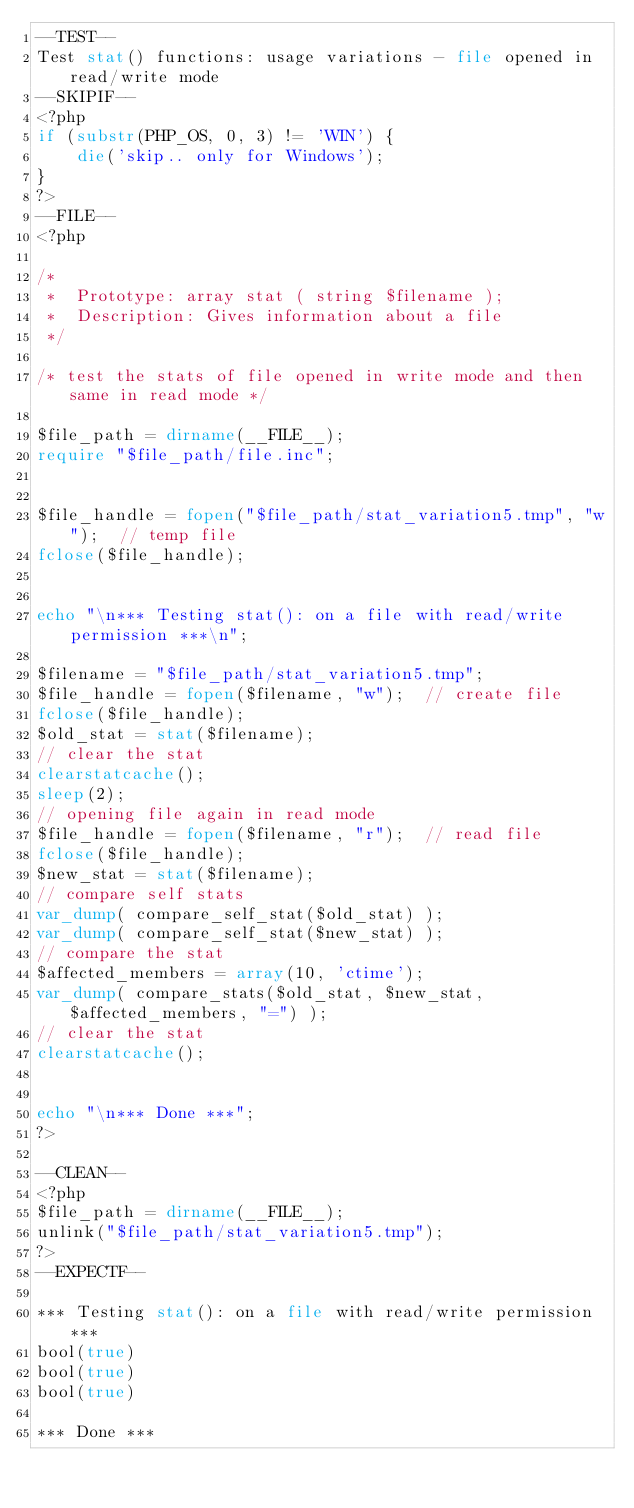Convert code to text. <code><loc_0><loc_0><loc_500><loc_500><_PHP_>--TEST--
Test stat() functions: usage variations - file opened in read/write mode
--SKIPIF--
<?php
if (substr(PHP_OS, 0, 3) != 'WIN') {
    die('skip.. only for Windows');
}
?>
--FILE--
<?php

/*
 *  Prototype: array stat ( string $filename );
 *  Description: Gives information about a file
 */

/* test the stats of file opened in write mode and then same in read mode */

$file_path = dirname(__FILE__);
require "$file_path/file.inc";


$file_handle = fopen("$file_path/stat_variation5.tmp", "w");  // temp file
fclose($file_handle);


echo "\n*** Testing stat(): on a file with read/write permission ***\n";

$filename = "$file_path/stat_variation5.tmp";
$file_handle = fopen($filename, "w");  // create file
fclose($file_handle);
$old_stat = stat($filename);
// clear the stat
clearstatcache();
sleep(2);
// opening file again in read mode
$file_handle = fopen($filename, "r");  // read file
fclose($file_handle);
$new_stat = stat($filename);
// compare self stats
var_dump( compare_self_stat($old_stat) );
var_dump( compare_self_stat($new_stat) );
// compare the stat
$affected_members = array(10, 'ctime');
var_dump( compare_stats($old_stat, $new_stat, $affected_members, "=") );
// clear the stat
clearstatcache();


echo "\n*** Done ***";
?>

--CLEAN--
<?php
$file_path = dirname(__FILE__);
unlink("$file_path/stat_variation5.tmp");
?>
--EXPECTF--

*** Testing stat(): on a file with read/write permission ***
bool(true)
bool(true)
bool(true)

*** Done ***

</code> 